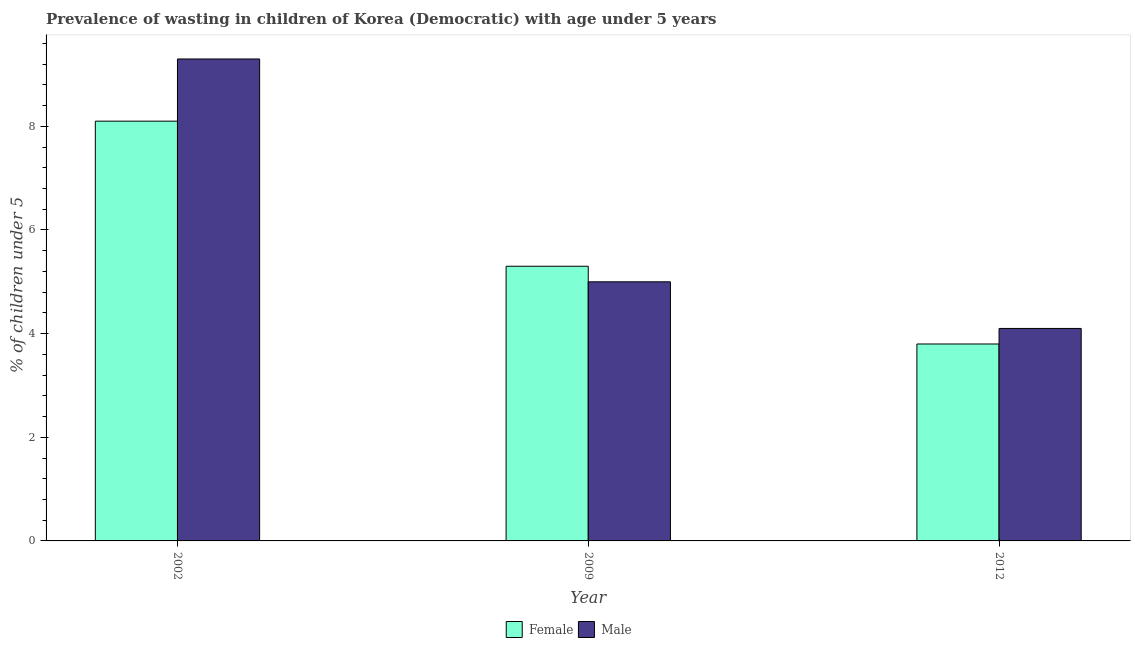How many different coloured bars are there?
Give a very brief answer. 2. Are the number of bars per tick equal to the number of legend labels?
Offer a terse response. Yes. What is the label of the 2nd group of bars from the left?
Make the answer very short. 2009. In how many cases, is the number of bars for a given year not equal to the number of legend labels?
Make the answer very short. 0. What is the percentage of undernourished female children in 2009?
Your response must be concise. 5.3. Across all years, what is the maximum percentage of undernourished female children?
Your answer should be compact. 8.1. Across all years, what is the minimum percentage of undernourished female children?
Your answer should be very brief. 3.8. What is the total percentage of undernourished male children in the graph?
Make the answer very short. 18.4. What is the difference between the percentage of undernourished male children in 2002 and that in 2012?
Make the answer very short. 5.2. What is the difference between the percentage of undernourished female children in 2009 and the percentage of undernourished male children in 2012?
Your response must be concise. 1.5. What is the average percentage of undernourished female children per year?
Offer a very short reply. 5.73. What is the ratio of the percentage of undernourished female children in 2002 to that in 2009?
Your answer should be compact. 1.53. Is the percentage of undernourished female children in 2009 less than that in 2012?
Provide a short and direct response. No. Is the difference between the percentage of undernourished female children in 2002 and 2009 greater than the difference between the percentage of undernourished male children in 2002 and 2009?
Offer a terse response. No. What is the difference between the highest and the second highest percentage of undernourished male children?
Ensure brevity in your answer.  4.3. What is the difference between the highest and the lowest percentage of undernourished female children?
Ensure brevity in your answer.  4.3. In how many years, is the percentage of undernourished female children greater than the average percentage of undernourished female children taken over all years?
Your answer should be compact. 1. What does the 1st bar from the left in 2012 represents?
Provide a short and direct response. Female. Are all the bars in the graph horizontal?
Give a very brief answer. No. How many years are there in the graph?
Your answer should be very brief. 3. What is the difference between two consecutive major ticks on the Y-axis?
Offer a terse response. 2. Are the values on the major ticks of Y-axis written in scientific E-notation?
Your response must be concise. No. Does the graph contain grids?
Ensure brevity in your answer.  No. What is the title of the graph?
Your answer should be compact. Prevalence of wasting in children of Korea (Democratic) with age under 5 years. What is the label or title of the X-axis?
Keep it short and to the point. Year. What is the label or title of the Y-axis?
Ensure brevity in your answer.   % of children under 5. What is the  % of children under 5 in Female in 2002?
Your answer should be compact. 8.1. What is the  % of children under 5 in Male in 2002?
Provide a succinct answer. 9.3. What is the  % of children under 5 in Female in 2009?
Keep it short and to the point. 5.3. What is the  % of children under 5 in Male in 2009?
Give a very brief answer. 5. What is the  % of children under 5 of Female in 2012?
Your answer should be compact. 3.8. What is the  % of children under 5 of Male in 2012?
Give a very brief answer. 4.1. Across all years, what is the maximum  % of children under 5 in Female?
Keep it short and to the point. 8.1. Across all years, what is the maximum  % of children under 5 of Male?
Your response must be concise. 9.3. Across all years, what is the minimum  % of children under 5 of Female?
Your response must be concise. 3.8. Across all years, what is the minimum  % of children under 5 in Male?
Make the answer very short. 4.1. What is the difference between the  % of children under 5 of Female in 2009 and that in 2012?
Your answer should be compact. 1.5. What is the difference between the  % of children under 5 of Male in 2009 and that in 2012?
Provide a succinct answer. 0.9. What is the difference between the  % of children under 5 in Female in 2002 and the  % of children under 5 in Male in 2009?
Provide a succinct answer. 3.1. What is the difference between the  % of children under 5 of Female in 2009 and the  % of children under 5 of Male in 2012?
Your answer should be compact. 1.2. What is the average  % of children under 5 in Female per year?
Give a very brief answer. 5.73. What is the average  % of children under 5 of Male per year?
Give a very brief answer. 6.13. In the year 2012, what is the difference between the  % of children under 5 of Female and  % of children under 5 of Male?
Provide a short and direct response. -0.3. What is the ratio of the  % of children under 5 in Female in 2002 to that in 2009?
Ensure brevity in your answer.  1.53. What is the ratio of the  % of children under 5 in Male in 2002 to that in 2009?
Provide a succinct answer. 1.86. What is the ratio of the  % of children under 5 of Female in 2002 to that in 2012?
Make the answer very short. 2.13. What is the ratio of the  % of children under 5 of Male in 2002 to that in 2012?
Provide a succinct answer. 2.27. What is the ratio of the  % of children under 5 in Female in 2009 to that in 2012?
Provide a succinct answer. 1.39. What is the ratio of the  % of children under 5 of Male in 2009 to that in 2012?
Make the answer very short. 1.22. What is the difference between the highest and the lowest  % of children under 5 in Male?
Provide a succinct answer. 5.2. 